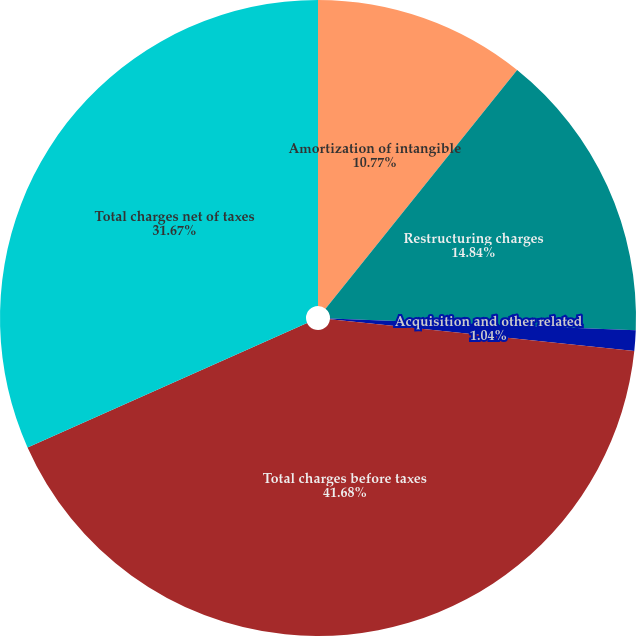Convert chart. <chart><loc_0><loc_0><loc_500><loc_500><pie_chart><fcel>Amortization of intangible<fcel>Restructuring charges<fcel>Acquisition and other related<fcel>Total charges before taxes<fcel>Total charges net of taxes<nl><fcel>10.77%<fcel>14.84%<fcel>1.04%<fcel>41.67%<fcel>31.67%<nl></chart> 